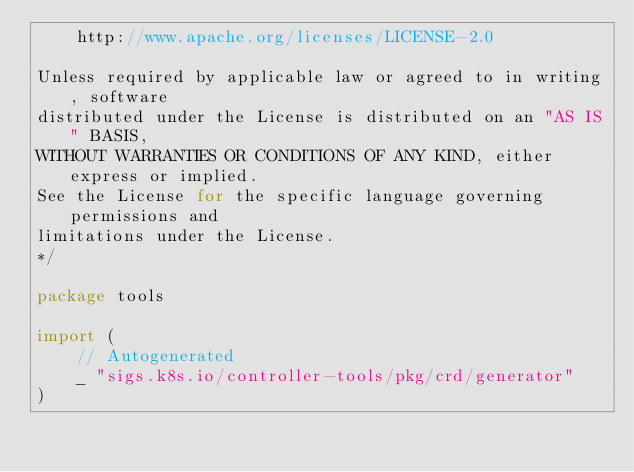<code> <loc_0><loc_0><loc_500><loc_500><_Go_>	http://www.apache.org/licenses/LICENSE-2.0

Unless required by applicable law or agreed to in writing, software
distributed under the License is distributed on an "AS IS" BASIS,
WITHOUT WARRANTIES OR CONDITIONS OF ANY KIND, either express or implied.
See the License for the specific language governing permissions and
limitations under the License.
*/

package tools

import (
	// Autogenerated
	_ "sigs.k8s.io/controller-tools/pkg/crd/generator"
)
</code> 